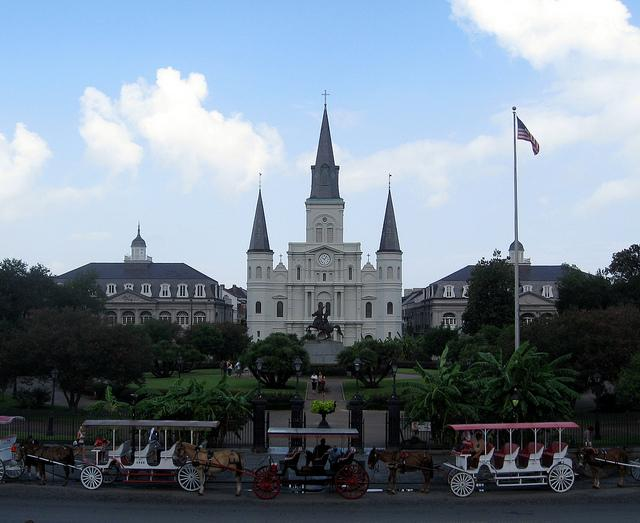What period of the day is it in the photo?

Choices:
A) late morning
B) night
C) evening
D) afternoon late morning 